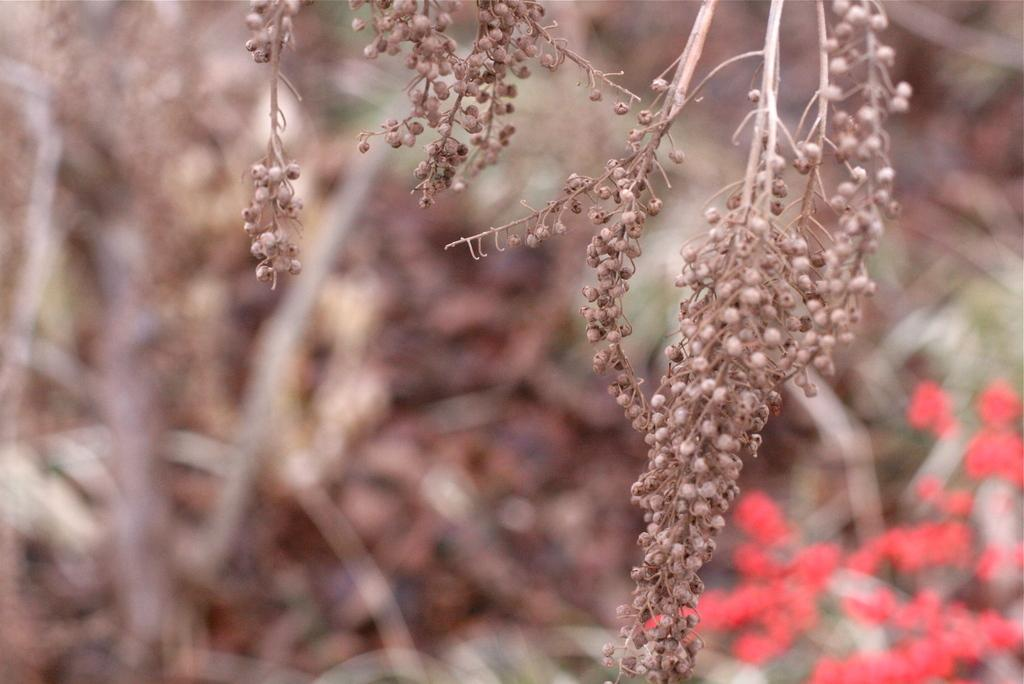What celestial bodies can be seen in the image? There are planets visible in the image. Can you describe the background of the image? The background of the image is blurred. What type of horse-drawn carriage can be seen in the image? There is no horse-drawn carriage present in the image; it features planets and a blurred background. 